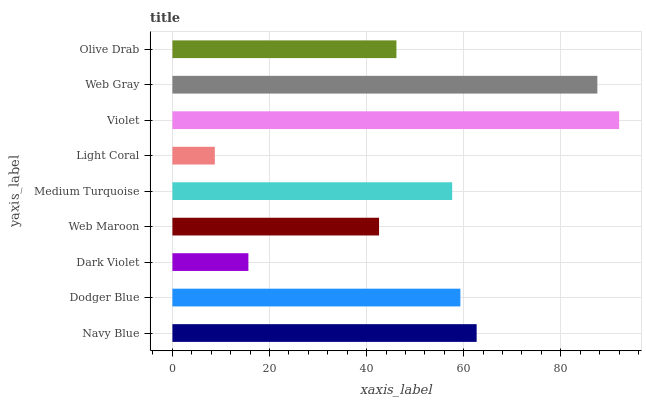Is Light Coral the minimum?
Answer yes or no. Yes. Is Violet the maximum?
Answer yes or no. Yes. Is Dodger Blue the minimum?
Answer yes or no. No. Is Dodger Blue the maximum?
Answer yes or no. No. Is Navy Blue greater than Dodger Blue?
Answer yes or no. Yes. Is Dodger Blue less than Navy Blue?
Answer yes or no. Yes. Is Dodger Blue greater than Navy Blue?
Answer yes or no. No. Is Navy Blue less than Dodger Blue?
Answer yes or no. No. Is Medium Turquoise the high median?
Answer yes or no. Yes. Is Medium Turquoise the low median?
Answer yes or no. Yes. Is Violet the high median?
Answer yes or no. No. Is Web Gray the low median?
Answer yes or no. No. 